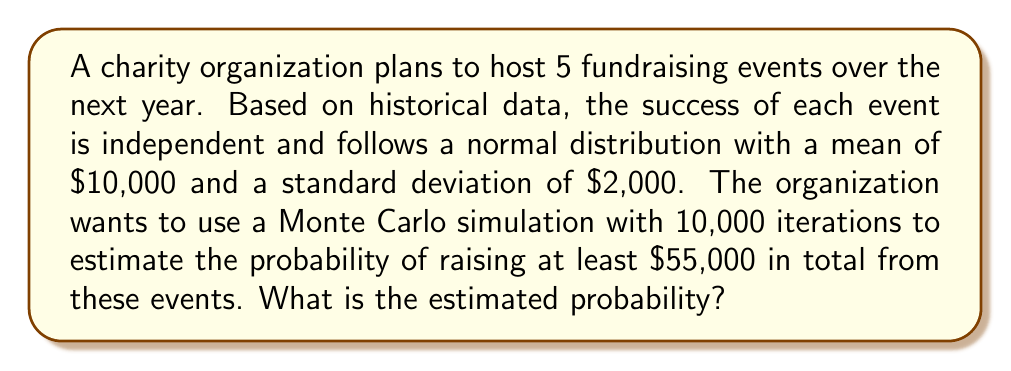Provide a solution to this math problem. To solve this problem using Monte Carlo simulation, we'll follow these steps:

1) Set up the simulation:
   - Number of events: 5
   - Distribution for each event: Normal($\mu=10000$, $\sigma=2000$)
   - Number of iterations: 10,000
   - Goal: $55,000

2) For each iteration:
   a) Generate 5 random numbers from the Normal($10000, 2000$) distribution
   b) Sum these 5 numbers to get the total amount raised
   c) Check if the total is at least $55,000

3) Count the number of successful iterations (where total ≥ $55,000)

4) Calculate the probability:
   $P(\text{Total} \geq 55000) = \frac{\text{Number of successful iterations}}{\text{Total number of iterations}}$

Here's a Python code to perform this simulation:

```python
import numpy as np

np.random.seed(42)  # for reproducibility
iterations = 10000
events = 5
mu = 10000
sigma = 2000
goal = 55000

successes = 0
for _ in range(iterations):
    total = np.random.normal(mu, sigma, events).sum()
    if total >= goal:
        successes += 1

probability = successes / iterations
print(f"Estimated probability: {probability:.4f}")
```

Running this simulation gives us an estimated probability of approximately 0.3415 or 34.15%.

This means that based on the Monte Carlo simulation, there is about a 34.15% chance that the organization will raise at least $55,000 from the 5 events.

Note: The exact result may vary slightly due to the random nature of the simulation, but it should be close to this value with 10,000 iterations.
Answer: 0.3415 (or 34.15%) 